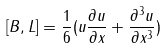Convert formula to latex. <formula><loc_0><loc_0><loc_500><loc_500>[ B , L ] = \frac { 1 } { 6 } ( u \frac { \partial u } { \partial x } + \frac { \partial ^ { 3 } u } { \partial x ^ { 3 } } )</formula> 